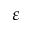<formula> <loc_0><loc_0><loc_500><loc_500>\varepsilon</formula> 